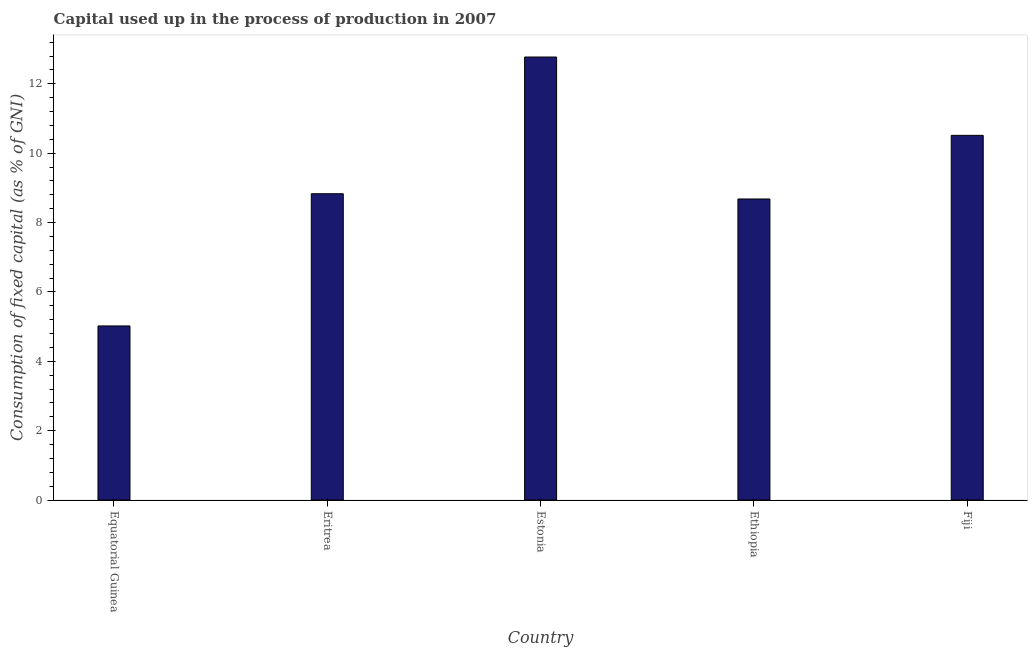Does the graph contain any zero values?
Your response must be concise. No. Does the graph contain grids?
Provide a succinct answer. No. What is the title of the graph?
Ensure brevity in your answer.  Capital used up in the process of production in 2007. What is the label or title of the X-axis?
Keep it short and to the point. Country. What is the label or title of the Y-axis?
Offer a terse response. Consumption of fixed capital (as % of GNI). What is the consumption of fixed capital in Eritrea?
Ensure brevity in your answer.  8.83. Across all countries, what is the maximum consumption of fixed capital?
Give a very brief answer. 12.77. Across all countries, what is the minimum consumption of fixed capital?
Make the answer very short. 5.02. In which country was the consumption of fixed capital maximum?
Ensure brevity in your answer.  Estonia. In which country was the consumption of fixed capital minimum?
Provide a succinct answer. Equatorial Guinea. What is the sum of the consumption of fixed capital?
Ensure brevity in your answer.  45.81. What is the difference between the consumption of fixed capital in Equatorial Guinea and Eritrea?
Provide a short and direct response. -3.81. What is the average consumption of fixed capital per country?
Provide a succinct answer. 9.16. What is the median consumption of fixed capital?
Keep it short and to the point. 8.83. In how many countries, is the consumption of fixed capital greater than 12.8 %?
Make the answer very short. 0. What is the ratio of the consumption of fixed capital in Eritrea to that in Fiji?
Your answer should be compact. 0.84. Is the difference between the consumption of fixed capital in Eritrea and Estonia greater than the difference between any two countries?
Offer a terse response. No. What is the difference between the highest and the second highest consumption of fixed capital?
Ensure brevity in your answer.  2.26. Is the sum of the consumption of fixed capital in Estonia and Fiji greater than the maximum consumption of fixed capital across all countries?
Your response must be concise. Yes. What is the difference between the highest and the lowest consumption of fixed capital?
Your answer should be compact. 7.75. How many bars are there?
Your answer should be very brief. 5. How many countries are there in the graph?
Make the answer very short. 5. Are the values on the major ticks of Y-axis written in scientific E-notation?
Your response must be concise. No. What is the Consumption of fixed capital (as % of GNI) in Equatorial Guinea?
Your answer should be compact. 5.02. What is the Consumption of fixed capital (as % of GNI) of Eritrea?
Offer a terse response. 8.83. What is the Consumption of fixed capital (as % of GNI) in Estonia?
Give a very brief answer. 12.77. What is the Consumption of fixed capital (as % of GNI) of Ethiopia?
Ensure brevity in your answer.  8.68. What is the Consumption of fixed capital (as % of GNI) of Fiji?
Keep it short and to the point. 10.51. What is the difference between the Consumption of fixed capital (as % of GNI) in Equatorial Guinea and Eritrea?
Provide a succinct answer. -3.81. What is the difference between the Consumption of fixed capital (as % of GNI) in Equatorial Guinea and Estonia?
Keep it short and to the point. -7.75. What is the difference between the Consumption of fixed capital (as % of GNI) in Equatorial Guinea and Ethiopia?
Give a very brief answer. -3.66. What is the difference between the Consumption of fixed capital (as % of GNI) in Equatorial Guinea and Fiji?
Make the answer very short. -5.5. What is the difference between the Consumption of fixed capital (as % of GNI) in Eritrea and Estonia?
Provide a succinct answer. -3.94. What is the difference between the Consumption of fixed capital (as % of GNI) in Eritrea and Ethiopia?
Offer a terse response. 0.15. What is the difference between the Consumption of fixed capital (as % of GNI) in Eritrea and Fiji?
Keep it short and to the point. -1.68. What is the difference between the Consumption of fixed capital (as % of GNI) in Estonia and Ethiopia?
Your answer should be compact. 4.09. What is the difference between the Consumption of fixed capital (as % of GNI) in Estonia and Fiji?
Provide a succinct answer. 2.26. What is the difference between the Consumption of fixed capital (as % of GNI) in Ethiopia and Fiji?
Provide a succinct answer. -1.83. What is the ratio of the Consumption of fixed capital (as % of GNI) in Equatorial Guinea to that in Eritrea?
Ensure brevity in your answer.  0.57. What is the ratio of the Consumption of fixed capital (as % of GNI) in Equatorial Guinea to that in Estonia?
Ensure brevity in your answer.  0.39. What is the ratio of the Consumption of fixed capital (as % of GNI) in Equatorial Guinea to that in Ethiopia?
Your answer should be compact. 0.58. What is the ratio of the Consumption of fixed capital (as % of GNI) in Equatorial Guinea to that in Fiji?
Provide a short and direct response. 0.48. What is the ratio of the Consumption of fixed capital (as % of GNI) in Eritrea to that in Estonia?
Ensure brevity in your answer.  0.69. What is the ratio of the Consumption of fixed capital (as % of GNI) in Eritrea to that in Fiji?
Your answer should be very brief. 0.84. What is the ratio of the Consumption of fixed capital (as % of GNI) in Estonia to that in Ethiopia?
Ensure brevity in your answer.  1.47. What is the ratio of the Consumption of fixed capital (as % of GNI) in Estonia to that in Fiji?
Provide a succinct answer. 1.22. What is the ratio of the Consumption of fixed capital (as % of GNI) in Ethiopia to that in Fiji?
Provide a short and direct response. 0.83. 